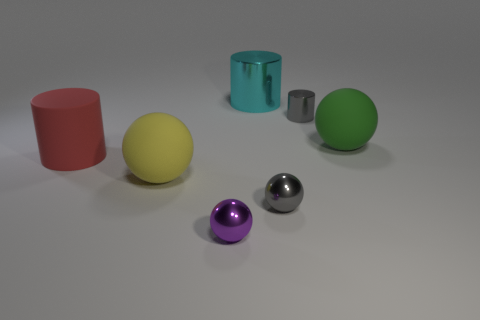Add 2 matte spheres. How many objects exist? 9 Subtract all cylinders. How many objects are left? 4 Add 7 big spheres. How many big spheres are left? 9 Add 6 big red cylinders. How many big red cylinders exist? 7 Subtract 0 blue balls. How many objects are left? 7 Subtract all big metallic things. Subtract all large cyan cylinders. How many objects are left? 5 